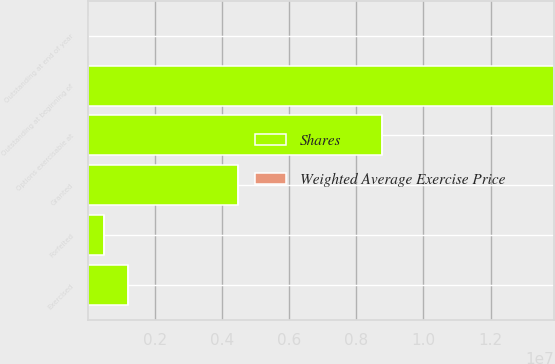Convert chart. <chart><loc_0><loc_0><loc_500><loc_500><stacked_bar_chart><ecel><fcel>Outstanding at beginning of<fcel>Granted<fcel>Exercised<fcel>Forfeited<fcel>Outstanding at end of year<fcel>Options exercisable at<nl><fcel>Shares<fcel>1.38891e+07<fcel>4.46849e+06<fcel>1.19642e+06<fcel>489550<fcel>46.83<fcel>8.7522e+06<nl><fcel>Weighted Average Exercise Price<fcel>43.26<fcel>35.95<fcel>30.92<fcel>46.83<fcel>42.08<fcel>40.91<nl></chart> 